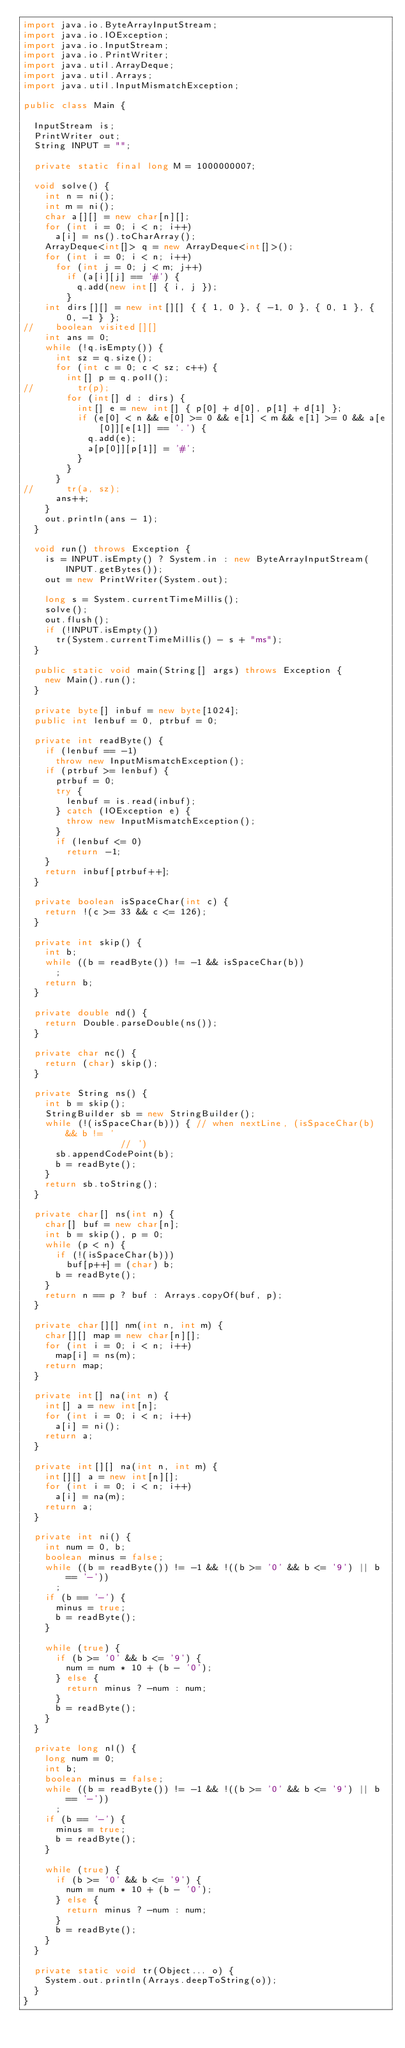Convert code to text. <code><loc_0><loc_0><loc_500><loc_500><_Java_>import java.io.ByteArrayInputStream;
import java.io.IOException;
import java.io.InputStream;
import java.io.PrintWriter;
import java.util.ArrayDeque;
import java.util.Arrays;
import java.util.InputMismatchException;

public class Main {

	InputStream is;
	PrintWriter out;
	String INPUT = "";

	private static final long M = 1000000007;

	void solve() {
		int n = ni();
		int m = ni();
		char a[][] = new char[n][];
		for (int i = 0; i < n; i++)
			a[i] = ns().toCharArray();
		ArrayDeque<int[]> q = new ArrayDeque<int[]>();
		for (int i = 0; i < n; i++)
			for (int j = 0; j < m; j++)
				if (a[i][j] == '#') {
					q.add(new int[] { i, j });
				}
		int dirs[][] = new int[][] { { 1, 0 }, { -1, 0 }, { 0, 1 }, { 0, -1 } };
//		boolean visited[][] 
		int ans = 0;
		while (!q.isEmpty()) {
			int sz = q.size();
			for (int c = 0; c < sz; c++) {
				int[] p = q.poll();
//				tr(p);
				for (int[] d : dirs) {
					int[] e = new int[] { p[0] + d[0], p[1] + d[1] };
					if (e[0] < n && e[0] >= 0 && e[1] < m && e[1] >= 0 && a[e[0]][e[1]] == '.') {
						q.add(e);
						a[p[0]][p[1]] = '#';
					}
				}
			}
//			tr(a, sz);
			ans++;
		}
		out.println(ans - 1);
	}

	void run() throws Exception {
		is = INPUT.isEmpty() ? System.in : new ByteArrayInputStream(INPUT.getBytes());
		out = new PrintWriter(System.out);

		long s = System.currentTimeMillis();
		solve();
		out.flush();
		if (!INPUT.isEmpty())
			tr(System.currentTimeMillis() - s + "ms");
	}

	public static void main(String[] args) throws Exception {
		new Main().run();
	}

	private byte[] inbuf = new byte[1024];
	public int lenbuf = 0, ptrbuf = 0;

	private int readByte() {
		if (lenbuf == -1)
			throw new InputMismatchException();
		if (ptrbuf >= lenbuf) {
			ptrbuf = 0;
			try {
				lenbuf = is.read(inbuf);
			} catch (IOException e) {
				throw new InputMismatchException();
			}
			if (lenbuf <= 0)
				return -1;
		}
		return inbuf[ptrbuf++];
	}

	private boolean isSpaceChar(int c) {
		return !(c >= 33 && c <= 126);
	}

	private int skip() {
		int b;
		while ((b = readByte()) != -1 && isSpaceChar(b))
			;
		return b;
	}

	private double nd() {
		return Double.parseDouble(ns());
	}

	private char nc() {
		return (char) skip();
	}

	private String ns() {
		int b = skip();
		StringBuilder sb = new StringBuilder();
		while (!(isSpaceChar(b))) { // when nextLine, (isSpaceChar(b) && b != '
									// ')
			sb.appendCodePoint(b);
			b = readByte();
		}
		return sb.toString();
	}

	private char[] ns(int n) {
		char[] buf = new char[n];
		int b = skip(), p = 0;
		while (p < n) {
			if (!(isSpaceChar(b)))
				buf[p++] = (char) b;
			b = readByte();
		}
		return n == p ? buf : Arrays.copyOf(buf, p);
	}

	private char[][] nm(int n, int m) {
		char[][] map = new char[n][];
		for (int i = 0; i < n; i++)
			map[i] = ns(m);
		return map;
	}

	private int[] na(int n) {
		int[] a = new int[n];
		for (int i = 0; i < n; i++)
			a[i] = ni();
		return a;
	}

	private int[][] na(int n, int m) {
		int[][] a = new int[n][];
		for (int i = 0; i < n; i++)
			a[i] = na(m);
		return a;
	}

	private int ni() {
		int num = 0, b;
		boolean minus = false;
		while ((b = readByte()) != -1 && !((b >= '0' && b <= '9') || b == '-'))
			;
		if (b == '-') {
			minus = true;
			b = readByte();
		}

		while (true) {
			if (b >= '0' && b <= '9') {
				num = num * 10 + (b - '0');
			} else {
				return minus ? -num : num;
			}
			b = readByte();
		}
	}

	private long nl() {
		long num = 0;
		int b;
		boolean minus = false;
		while ((b = readByte()) != -1 && !((b >= '0' && b <= '9') || b == '-'))
			;
		if (b == '-') {
			minus = true;
			b = readByte();
		}

		while (true) {
			if (b >= '0' && b <= '9') {
				num = num * 10 + (b - '0');
			} else {
				return minus ? -num : num;
			}
			b = readByte();
		}
	}

	private static void tr(Object... o) {
		System.out.println(Arrays.deepToString(o));
	}
}</code> 